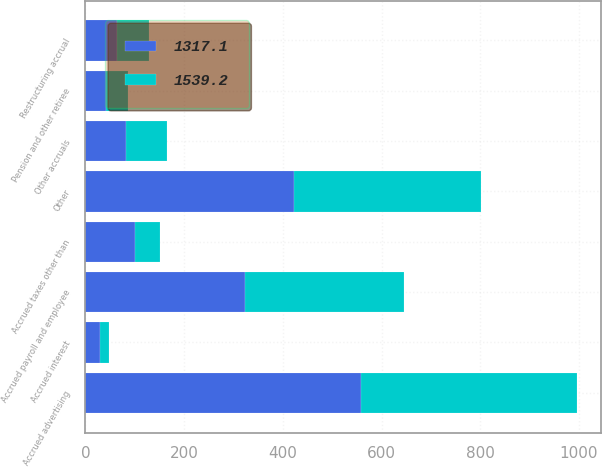Convert chart. <chart><loc_0><loc_0><loc_500><loc_500><stacked_bar_chart><ecel><fcel>Other accruals<fcel>Accrued advertising<fcel>Accrued payroll and employee<fcel>Accrued taxes other than<fcel>Restructuring accrual<fcel>Pension and other retiree<fcel>Accrued interest<fcel>Other<nl><fcel>1317.1<fcel>82.95<fcel>557.4<fcel>323.4<fcel>101.2<fcel>63.6<fcel>42.6<fcel>28.6<fcel>422.4<nl><fcel>1539.2<fcel>82.95<fcel>438.4<fcel>322.5<fcel>49.2<fcel>64.7<fcel>44.3<fcel>19.1<fcel>378.9<nl></chart> 